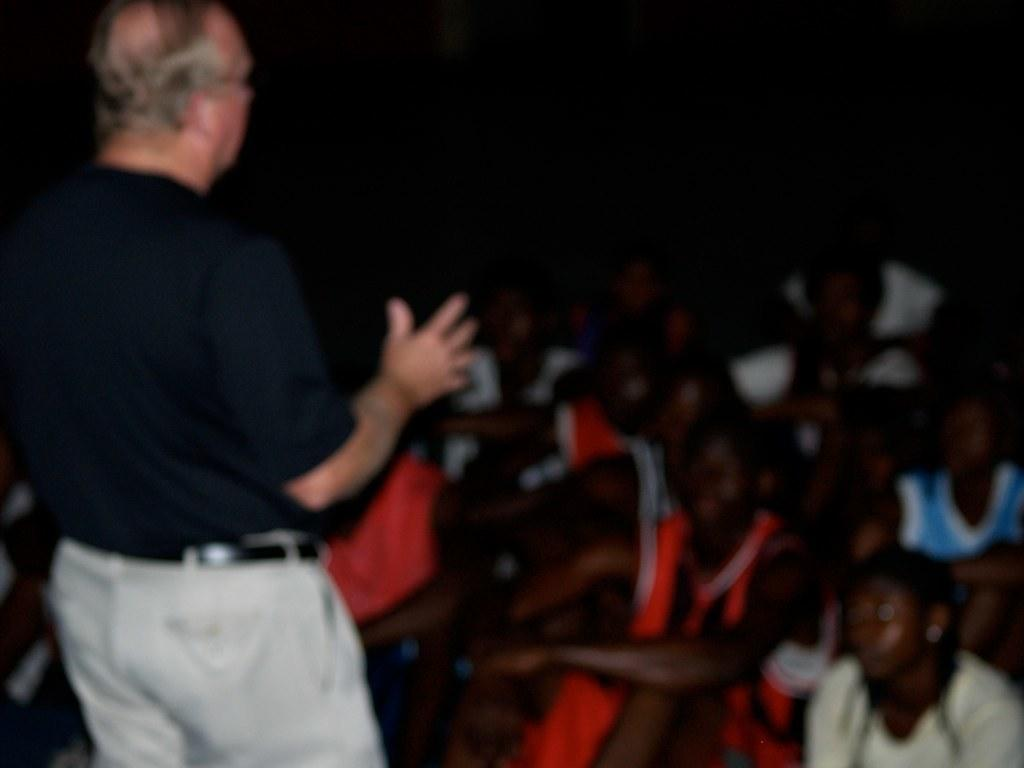What is the main subject of the image? There is a person standing in the image. What is the standing person wearing? The person is wearing a black and white dress. What are the people in the image doing? The people sitting in front of the standing person are likely observing or listening to them. What color is the background of the image? The background of the image is black in color. What type of throat lozenges can be seen in the image? There are no throat lozenges present in the image. Can you tell me what year the image was taken? The provided facts do not include information about the year the image was taken. 